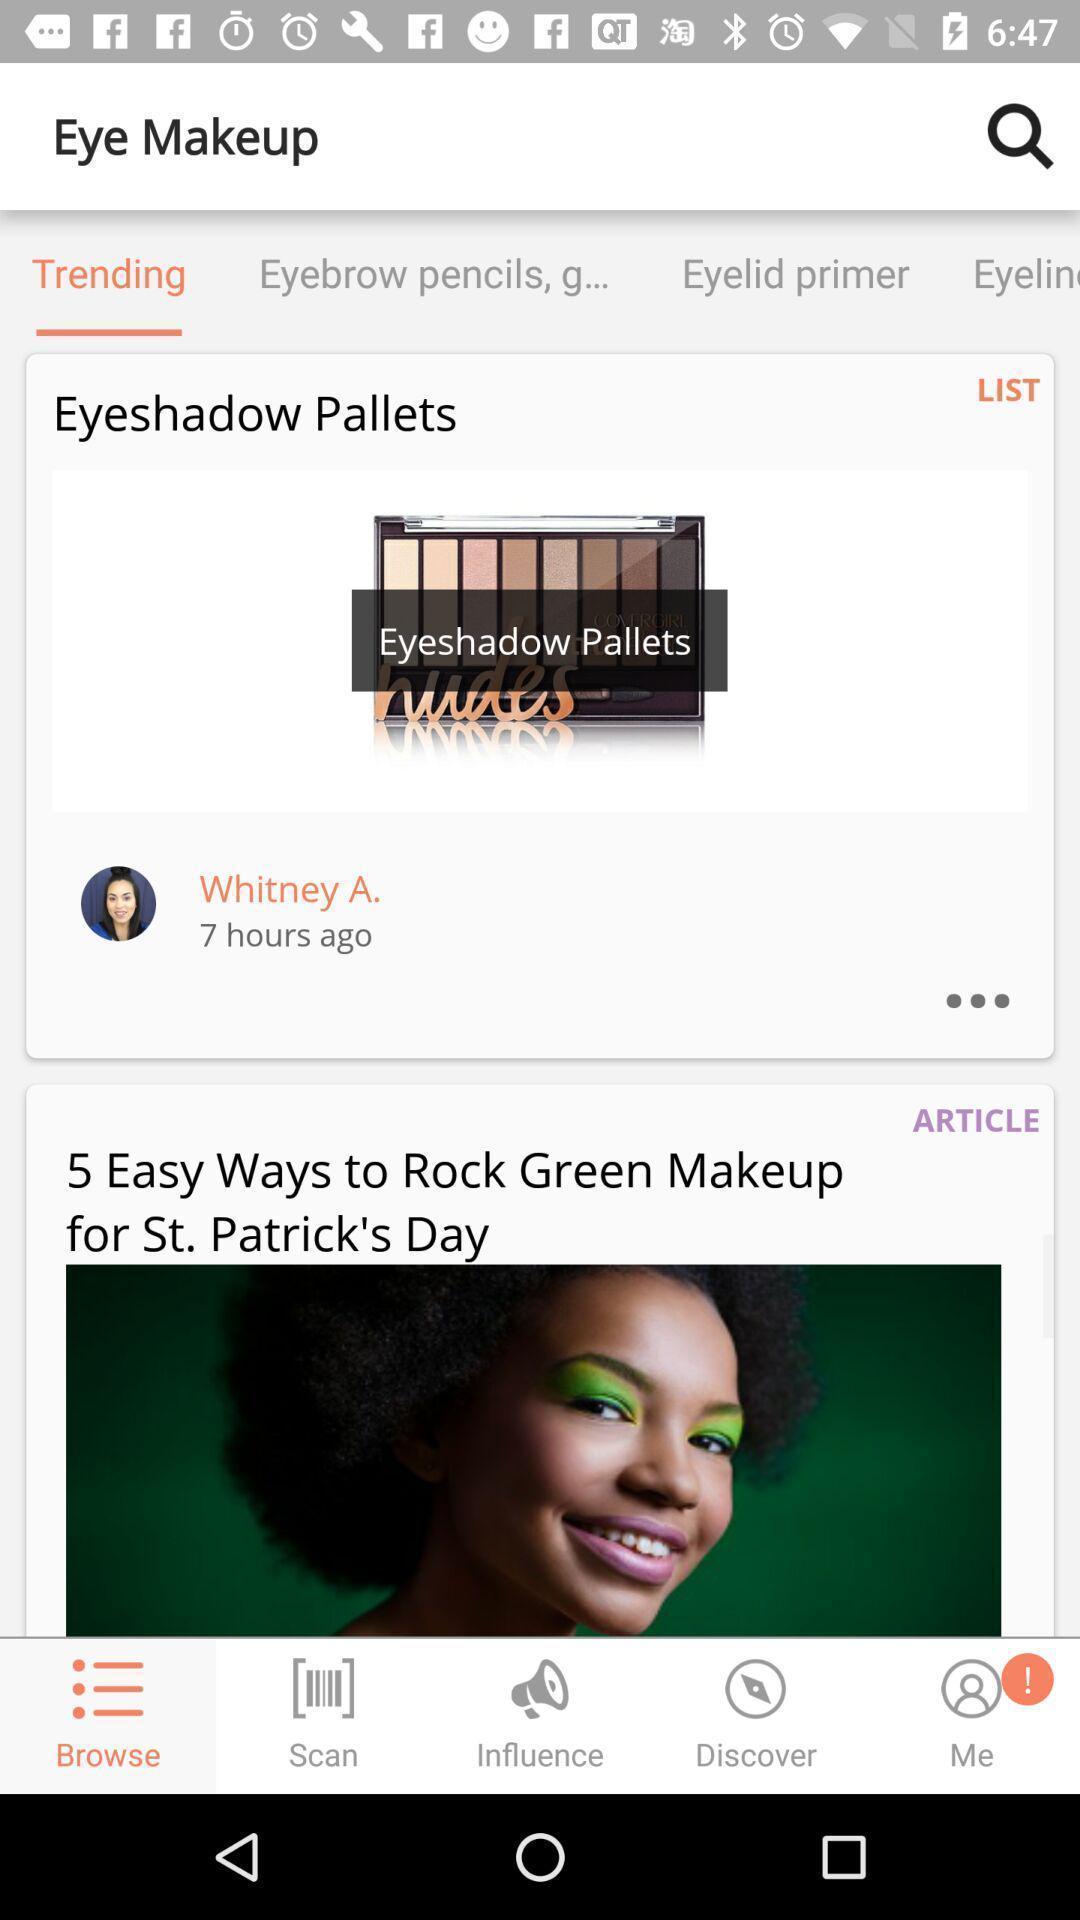Describe the content in this image. Trending page in shopping app. 